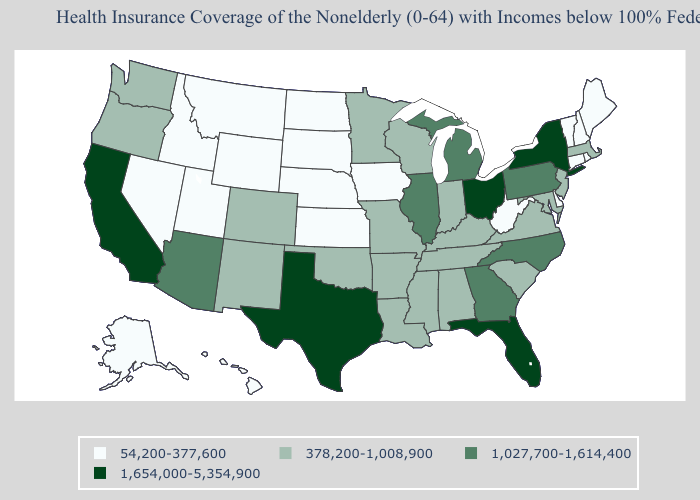Does the map have missing data?
Write a very short answer. No. What is the highest value in states that border Kentucky?
Write a very short answer. 1,654,000-5,354,900. What is the value of West Virginia?
Concise answer only. 54,200-377,600. Does Oklahoma have a higher value than Alaska?
Concise answer only. Yes. Does Idaho have the lowest value in the USA?
Keep it brief. Yes. What is the value of Kentucky?
Quick response, please. 378,200-1,008,900. Name the states that have a value in the range 378,200-1,008,900?
Answer briefly. Alabama, Arkansas, Colorado, Indiana, Kentucky, Louisiana, Maryland, Massachusetts, Minnesota, Mississippi, Missouri, New Jersey, New Mexico, Oklahoma, Oregon, South Carolina, Tennessee, Virginia, Washington, Wisconsin. Name the states that have a value in the range 1,027,700-1,614,400?
Give a very brief answer. Arizona, Georgia, Illinois, Michigan, North Carolina, Pennsylvania. What is the value of Mississippi?
Be succinct. 378,200-1,008,900. Does New Mexico have a higher value than Montana?
Be succinct. Yes. Which states have the highest value in the USA?
Concise answer only. California, Florida, New York, Ohio, Texas. What is the value of Hawaii?
Write a very short answer. 54,200-377,600. Among the states that border Montana , which have the highest value?
Keep it brief. Idaho, North Dakota, South Dakota, Wyoming. Does North Carolina have the highest value in the South?
Keep it brief. No. 